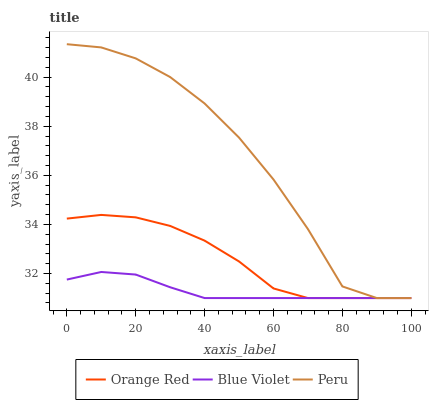Does Blue Violet have the minimum area under the curve?
Answer yes or no. Yes. Does Peru have the maximum area under the curve?
Answer yes or no. Yes. Does Orange Red have the minimum area under the curve?
Answer yes or no. No. Does Orange Red have the maximum area under the curve?
Answer yes or no. No. Is Blue Violet the smoothest?
Answer yes or no. Yes. Is Peru the roughest?
Answer yes or no. Yes. Is Orange Red the smoothest?
Answer yes or no. No. Is Orange Red the roughest?
Answer yes or no. No. Does Peru have the lowest value?
Answer yes or no. Yes. Does Peru have the highest value?
Answer yes or no. Yes. Does Orange Red have the highest value?
Answer yes or no. No. Does Blue Violet intersect Orange Red?
Answer yes or no. Yes. Is Blue Violet less than Orange Red?
Answer yes or no. No. Is Blue Violet greater than Orange Red?
Answer yes or no. No. 